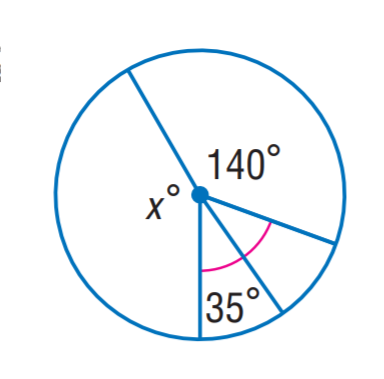Answer the mathemtical geometry problem and directly provide the correct option letter.
Question: Find x.
Choices: A: 70 B: 110 C: 140 D: 150 D 